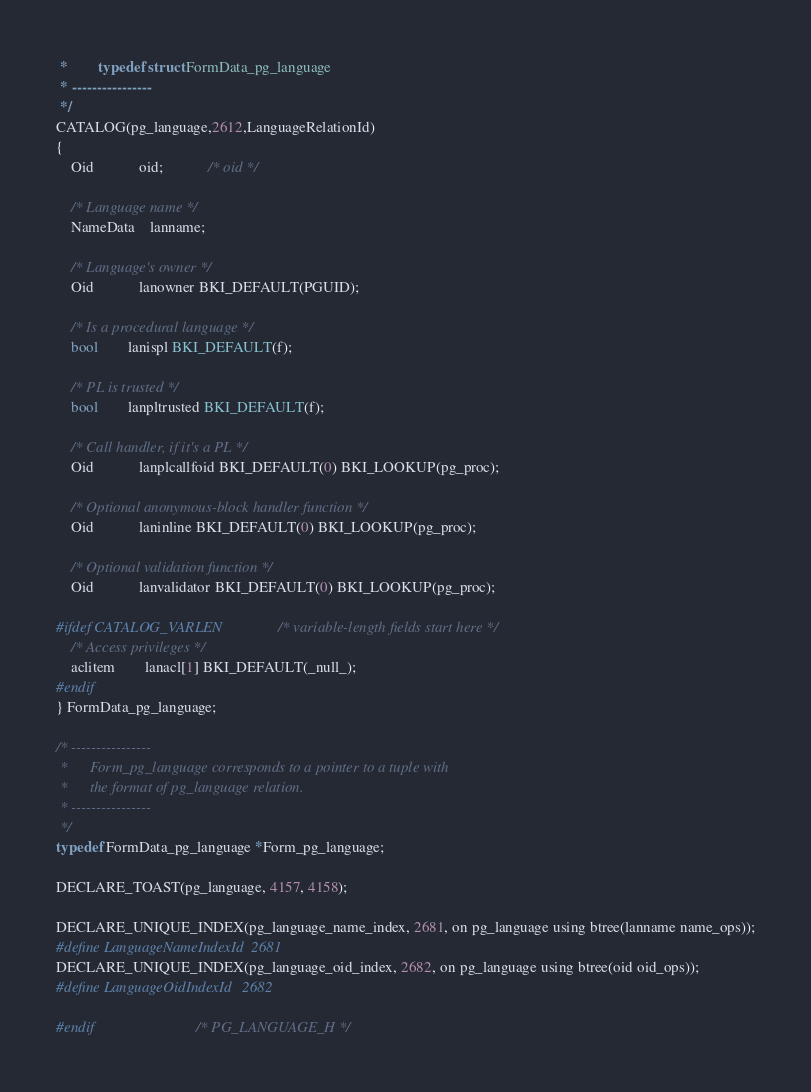<code> <loc_0><loc_0><loc_500><loc_500><_C_> *		typedef struct FormData_pg_language
 * ----------------
 */
CATALOG(pg_language,2612,LanguageRelationId)
{
	Oid			oid;			/* oid */

	/* Language name */
	NameData	lanname;

	/* Language's owner */
	Oid			lanowner BKI_DEFAULT(PGUID);

	/* Is a procedural language */
	bool		lanispl BKI_DEFAULT(f);

	/* PL is trusted */
	bool		lanpltrusted BKI_DEFAULT(f);

	/* Call handler, if it's a PL */
	Oid			lanplcallfoid BKI_DEFAULT(0) BKI_LOOKUP(pg_proc);

	/* Optional anonymous-block handler function */
	Oid			laninline BKI_DEFAULT(0) BKI_LOOKUP(pg_proc);

	/* Optional validation function */
	Oid			lanvalidator BKI_DEFAULT(0) BKI_LOOKUP(pg_proc);

#ifdef CATALOG_VARLEN			/* variable-length fields start here */
	/* Access privileges */
	aclitem		lanacl[1] BKI_DEFAULT(_null_);
#endif
} FormData_pg_language;

/* ----------------
 *		Form_pg_language corresponds to a pointer to a tuple with
 *		the format of pg_language relation.
 * ----------------
 */
typedef FormData_pg_language *Form_pg_language;

DECLARE_TOAST(pg_language, 4157, 4158);

DECLARE_UNIQUE_INDEX(pg_language_name_index, 2681, on pg_language using btree(lanname name_ops));
#define LanguageNameIndexId  2681
DECLARE_UNIQUE_INDEX(pg_language_oid_index, 2682, on pg_language using btree(oid oid_ops));
#define LanguageOidIndexId	2682

#endif							/* PG_LANGUAGE_H */
</code> 